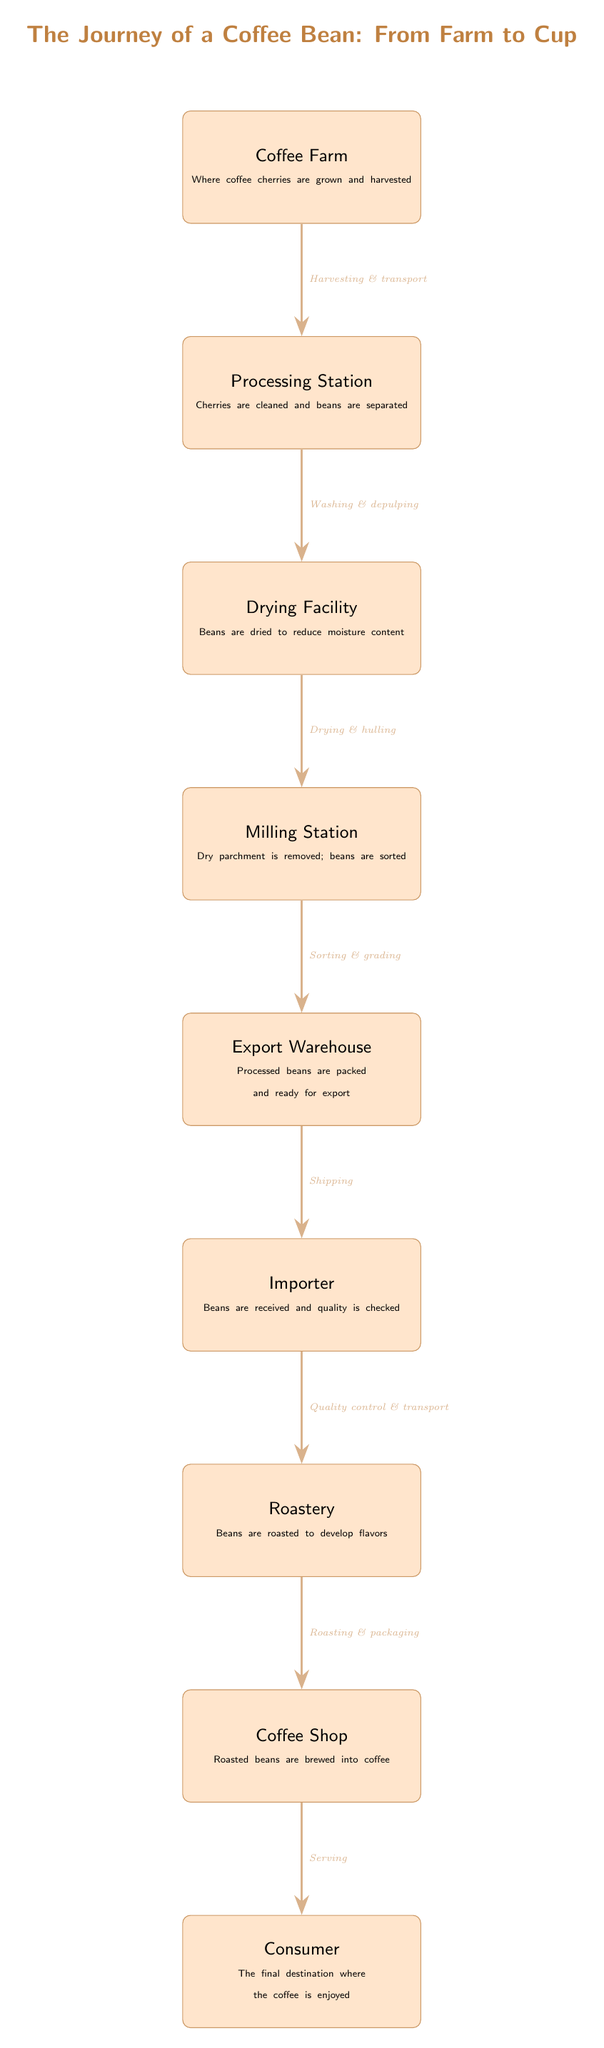What is the first stage in the journey of a coffee bean? The diagram clearly indicates that the first stage is the "Coffee Farm," where coffee cherries are initially grown and harvested.
Answer: Coffee Farm How many total stages are there in the coffee journey? Counting the nodes from "Coffee Farm" to "Consumer," there are a total of eight distinct stages that the coffee bean goes through before reaching the consumer.
Answer: Eight What process follows the "Processing Station"? According to the arrows in the diagram, after the "Processing Station" comes the "Drying Facility," indicating that this is the next step in the journey after processing the cherries.
Answer: Drying Facility What happens to coffee beans at the roastery? At the "Roastery," the beans undergo "Roasting to develop flavors," which is a crucial step in preparing the beans for brewing and ultimately serving.
Answer: Roasting What type of facility comes after the "Export Warehouse"? The diagram illustrates that the "Importer" facility is the next stage following the "Export Warehouse," where the processed beans are received and checked for quality.
Answer: Importer What method is applied just before beans reach the consumer? The last preparatory action before coffee reaches the consumer is "Serving," which takes place at the "Coffee Shop," indicating the final step in the supply chain.
Answer: Serving What type of control is conducted at the importer stage? The diagram specifies that at the "Importer," there is a process of "Quality control," which ensures that the beans meet certain standards before moving on to the next stage.
Answer: Quality control Which process is indicated between "Milling Station" and "Export Warehouse"? The arrow between these two stages reveals that the process involved is "Sorting and grading," ensuring that the beans are adequately prepared for export.
Answer: Sorting and grading What is the final destination of the journey outlined in the diagram? The flow of the diagram culminates at the "Consumer," who represents the final destination where the coffee is ultimately enjoyed.
Answer: Consumer 